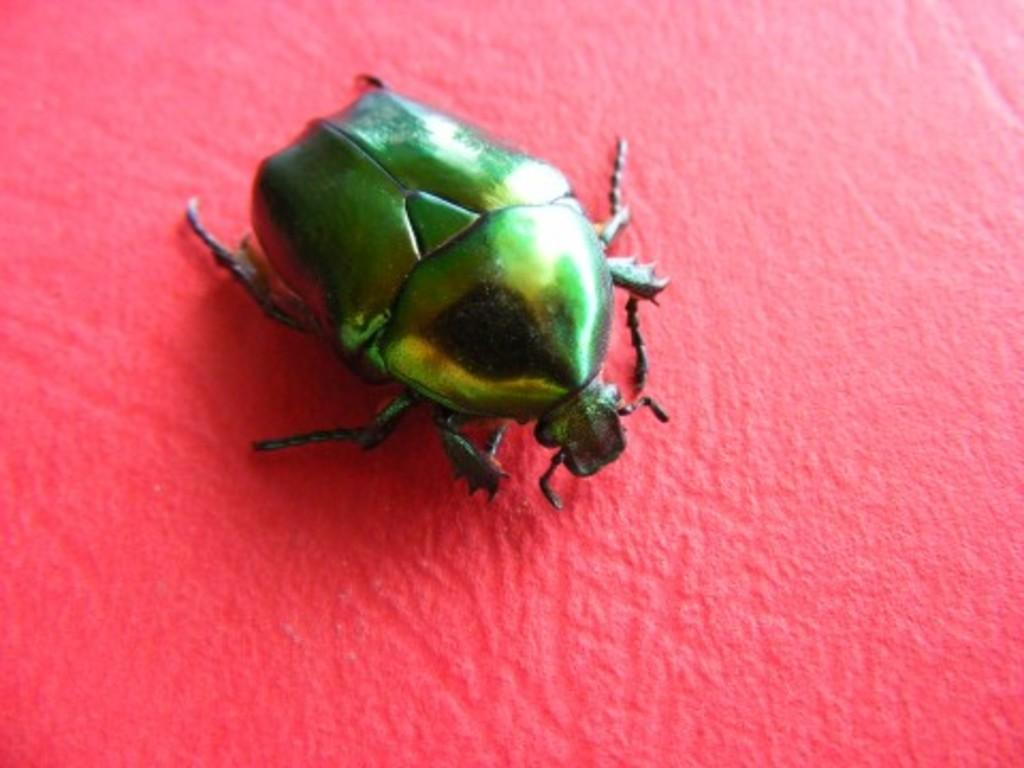What is present in the picture? There is a bug in the picture. What is the color of the surface the bug is on? The bug is on a pink surface. Can you describe the bug's physical features? The bug has a body, head, and legs. What time does the clock show in the image? There is no clock present in the image. What type of rock is visible in the image? There is no rock present in the image. 